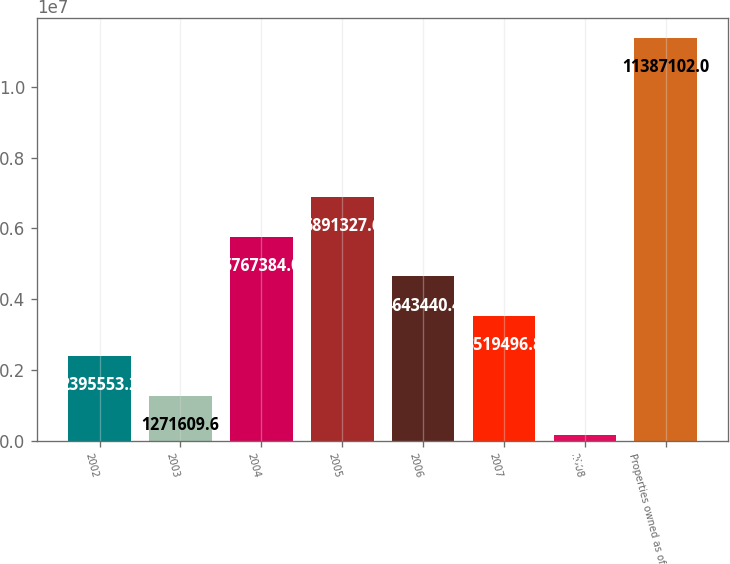Convert chart. <chart><loc_0><loc_0><loc_500><loc_500><bar_chart><fcel>2002<fcel>2003<fcel>2004<fcel>2005<fcel>2006<fcel>2007<fcel>2008<fcel>Properties owned as of<nl><fcel>2.39555e+06<fcel>1.27161e+06<fcel>5.76738e+06<fcel>6.89133e+06<fcel>4.64344e+06<fcel>3.5195e+06<fcel>147666<fcel>1.13871e+07<nl></chart> 